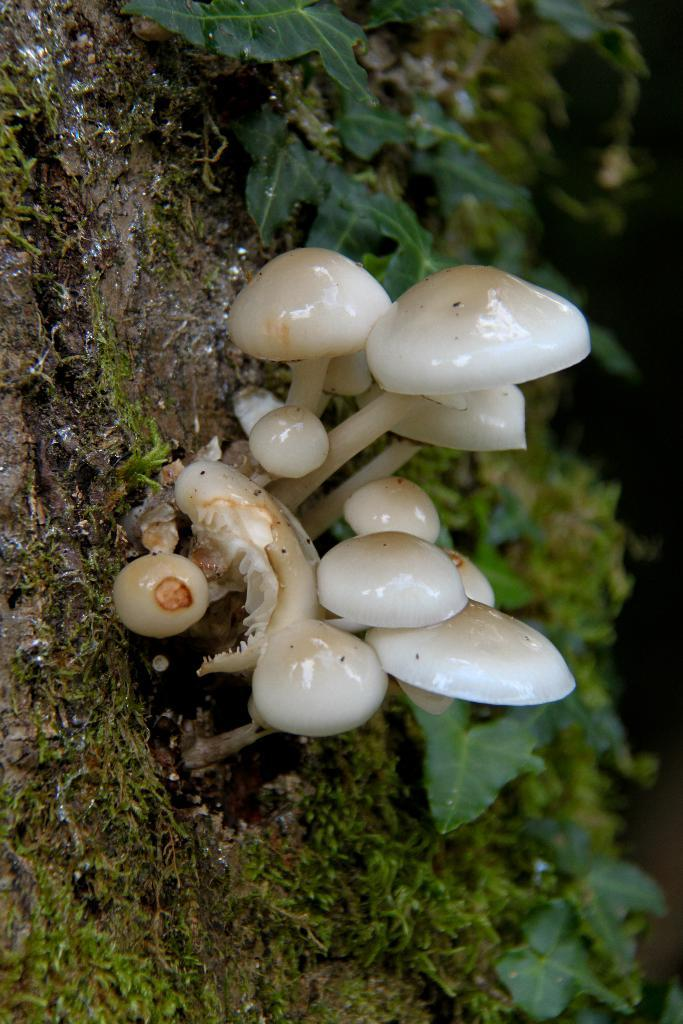What type of vegetation can be seen on the ground in the image? There are mushrooms on the ground in the image. What can be seen in the background of the image? There are leaves visible in the background of the image. What type of tramp is visible in the image? There is no tramp present in the image. What type of celery can be seen growing in the image? There is no celery present in the image. 